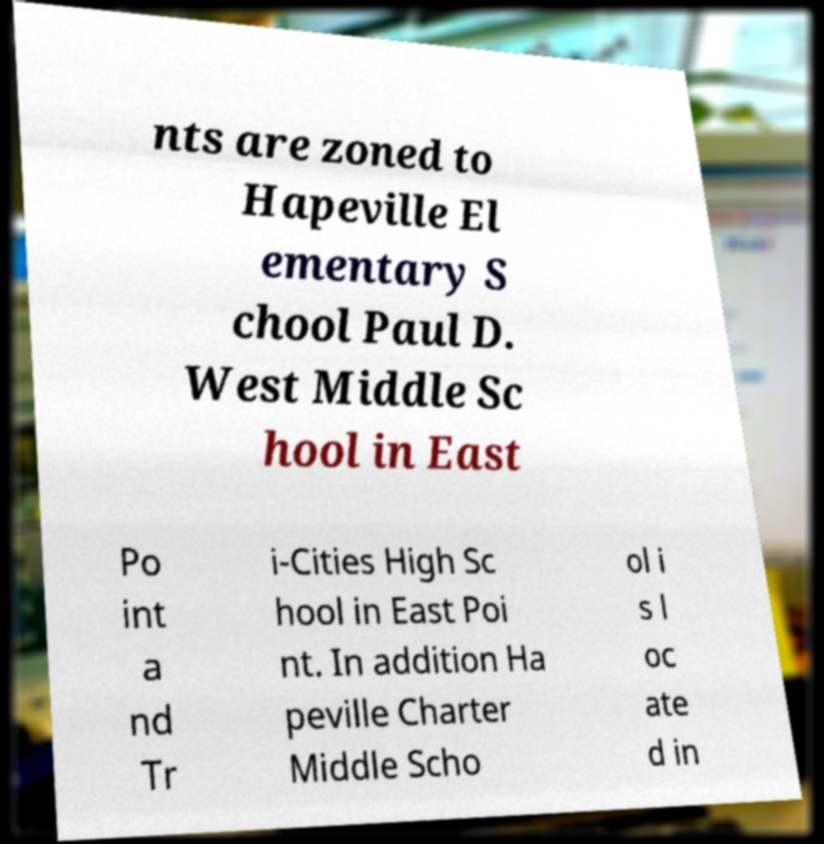There's text embedded in this image that I need extracted. Can you transcribe it verbatim? nts are zoned to Hapeville El ementary S chool Paul D. West Middle Sc hool in East Po int a nd Tr i-Cities High Sc hool in East Poi nt. In addition Ha peville Charter Middle Scho ol i s l oc ate d in 